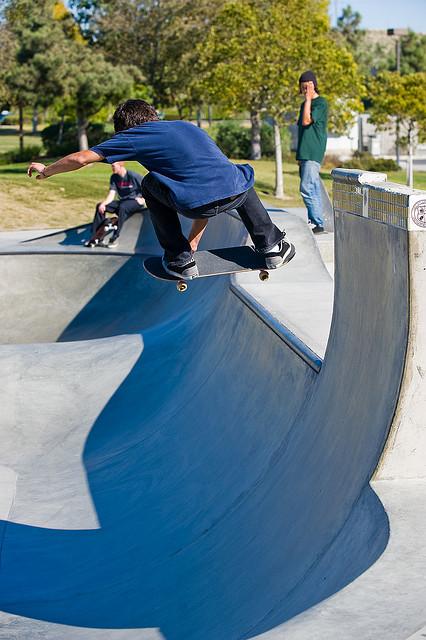The skateboard has how many wheels on it?
Be succinct. 4. What color is the skate ramp?
Short answer required. Gray. What are the people doing?
Keep it brief. Skateboarding. 